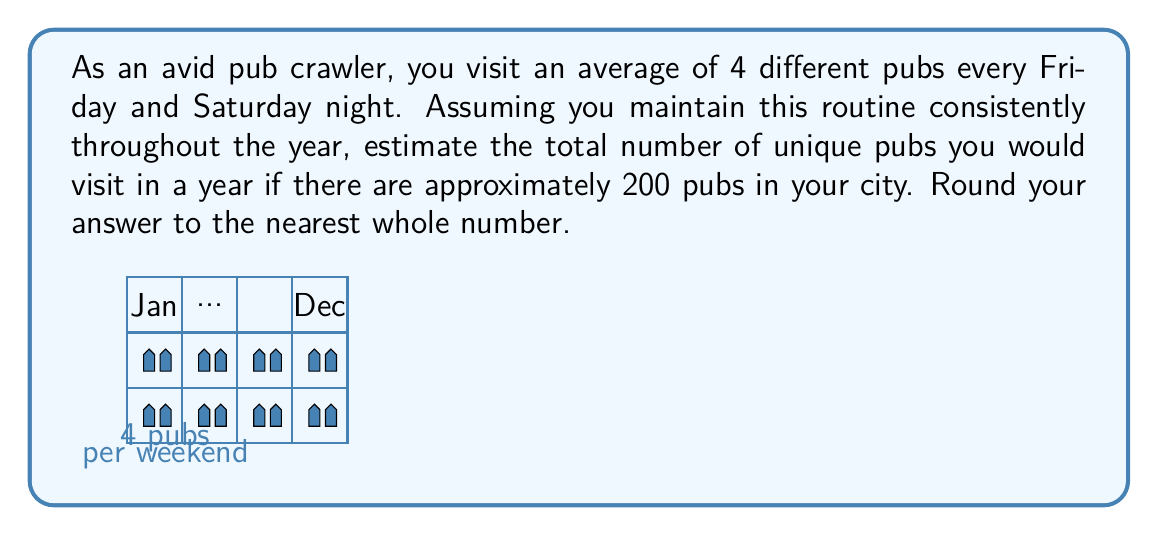Provide a solution to this math problem. Let's break this down step-by-step:

1) First, calculate the number of pubs visited per week:
   $$ \text{Pubs per week} = 4 \text{ (Friday)} + 4 \text{ (Saturday)} = 8 \text{ pubs} $$

2) Now, calculate the number of weeks in a year:
   $$ \text{Weeks in a year} = 52 $$

3) Calculate the total number of pub visits in a year:
   $$ \text{Total visits} = 8 \text{ pubs/week} \times 52 \text{ weeks} = 416 \text{ visits} $$

4) However, this doesn't account for repeat visits. With 200 pubs in the city, you're likely to start revisiting pubs before you've been to all of them.

5) To estimate unique pubs visited, we can use the concept of the "Coupon collector's problem". A simplified approximation suggests that after visiting about 75% of the total pubs, you'll start revisiting more frequently.

6) Therefore, we can estimate:
   $$ \text{Unique pubs} \approx 75\% \times 200 = 150 \text{ pubs} $$

7) Rounding to the nearest whole number, our estimate remains 150 pubs.
Answer: 150 pubs 